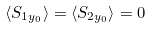Convert formula to latex. <formula><loc_0><loc_0><loc_500><loc_500>\langle { S _ { 1 { y _ { 0 } } } } \rangle = \langle { S _ { 2 { y _ { 0 } } } } \rangle = 0</formula> 